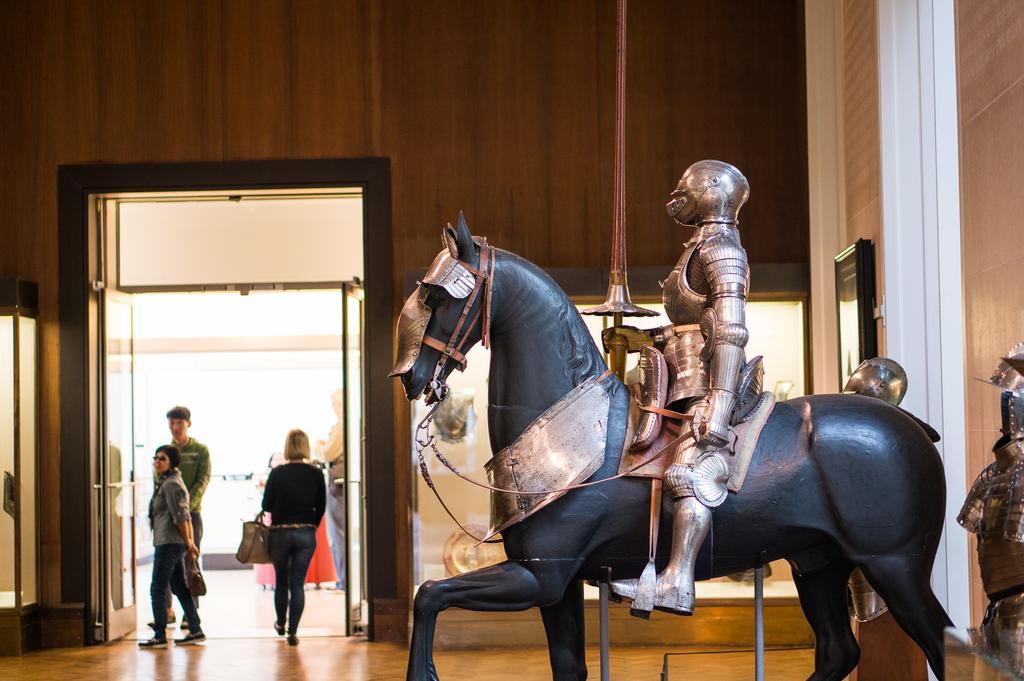Describe this image in one or two sentences. In this image we can see statue of a horse on the right side. On the horse there is a statue of a person wearing helmet and holding something in the hand is sitting. Also there are other statues. In the back there is a wall. There are doors. Near to the door there are few people. Some are holding bags. 